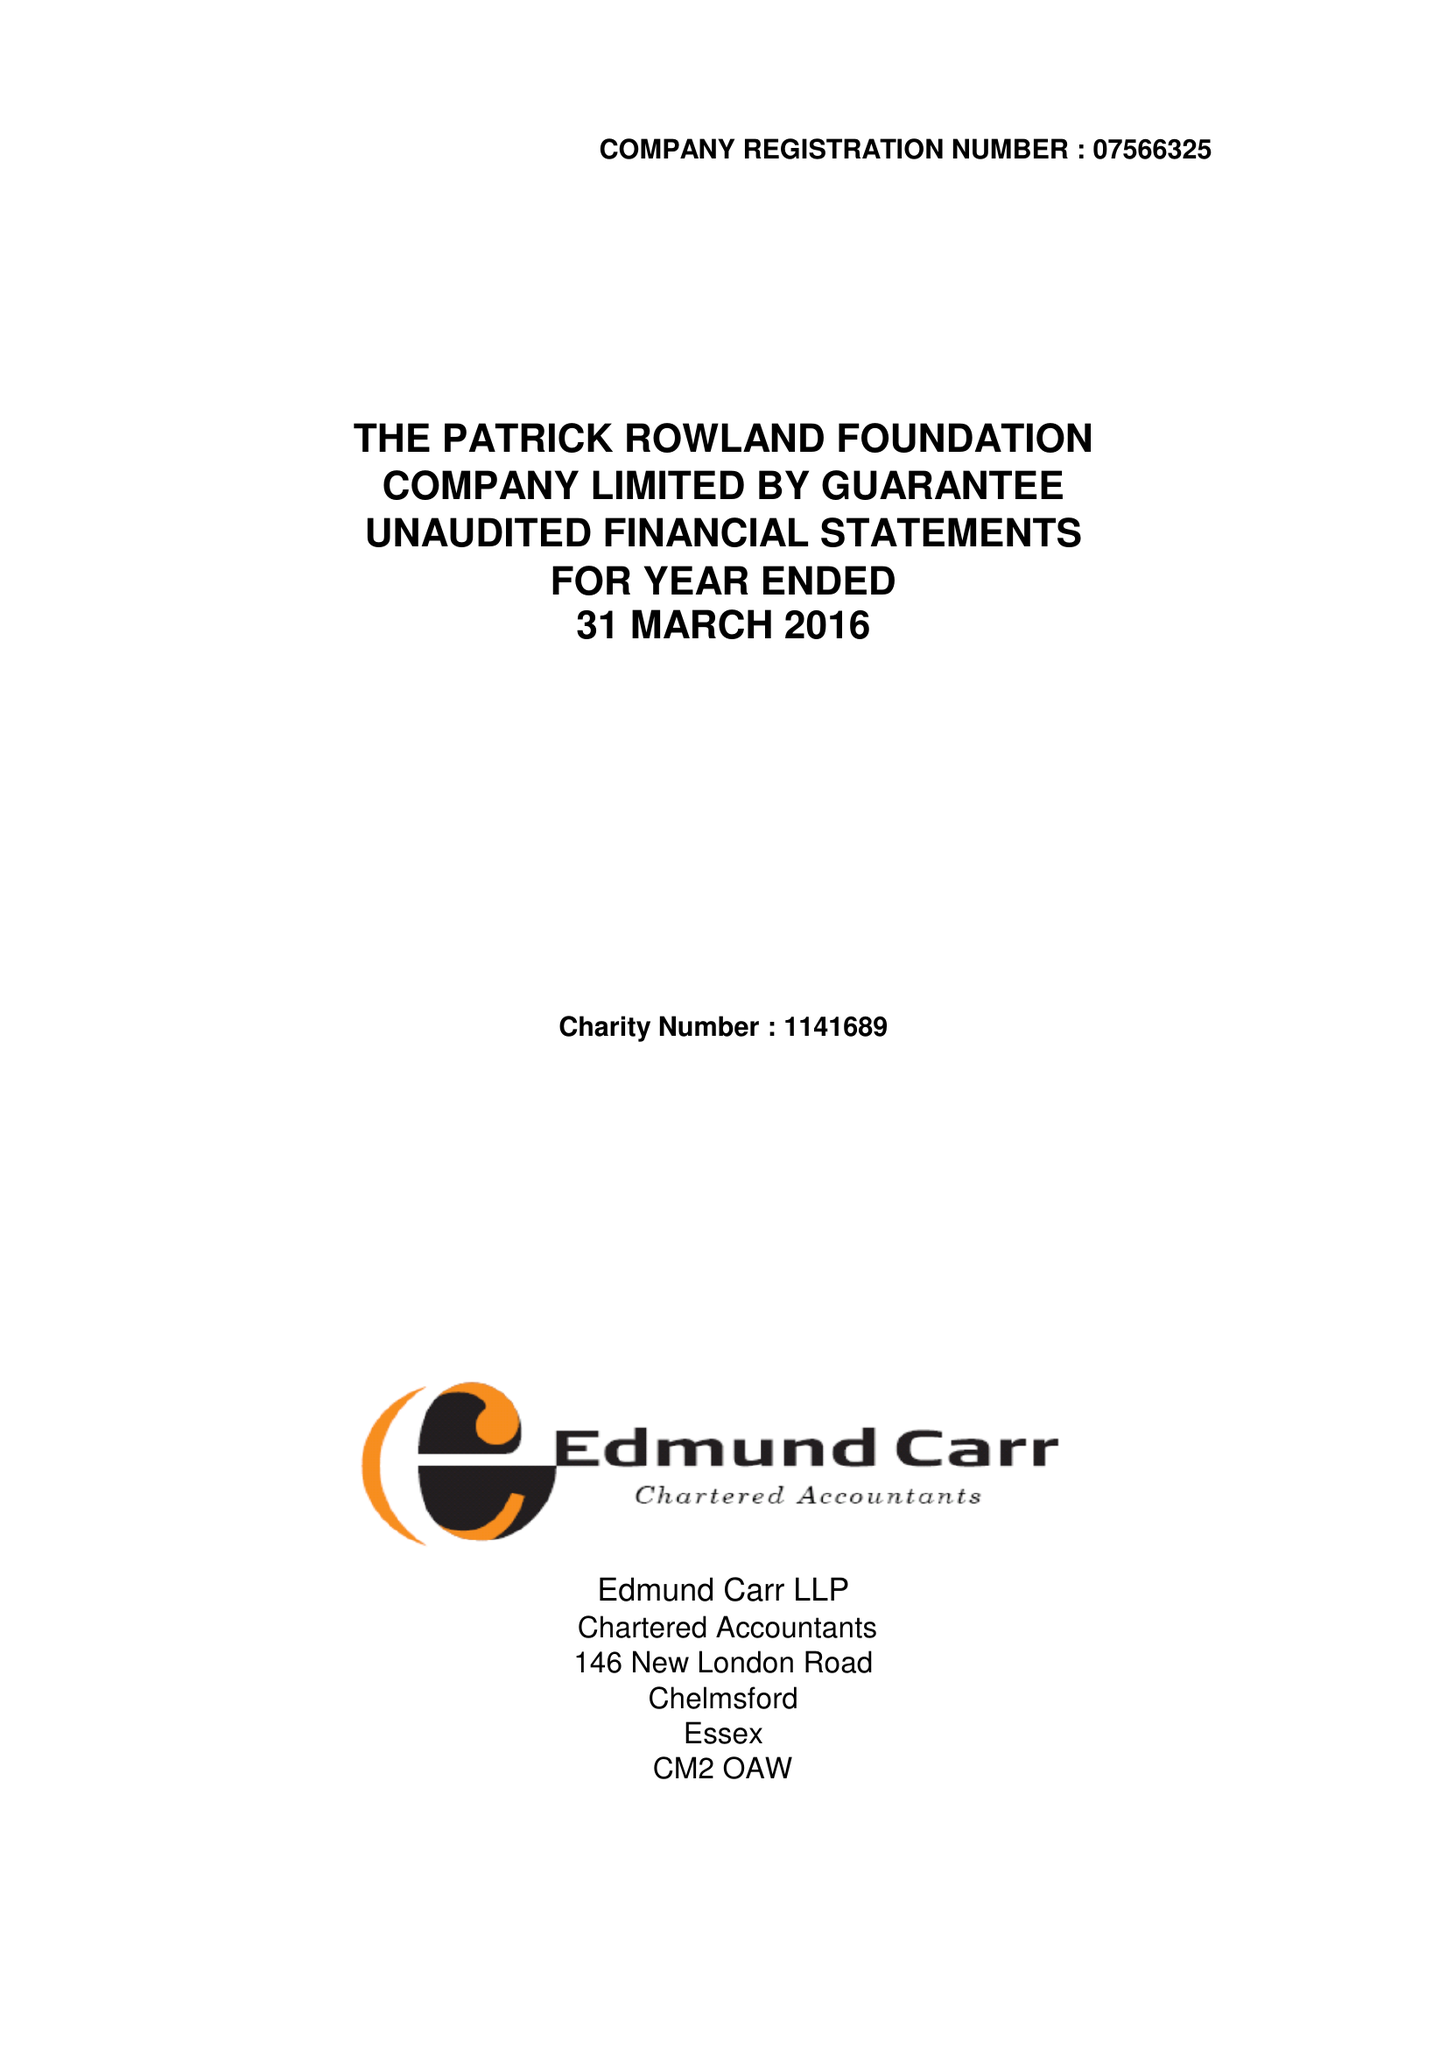What is the value for the charity_number?
Answer the question using a single word or phrase. 1141689 